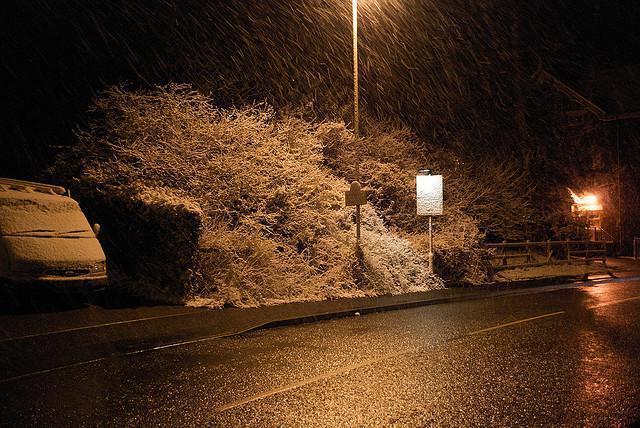How many cars are in the photo?
Give a very brief answer. 1. 